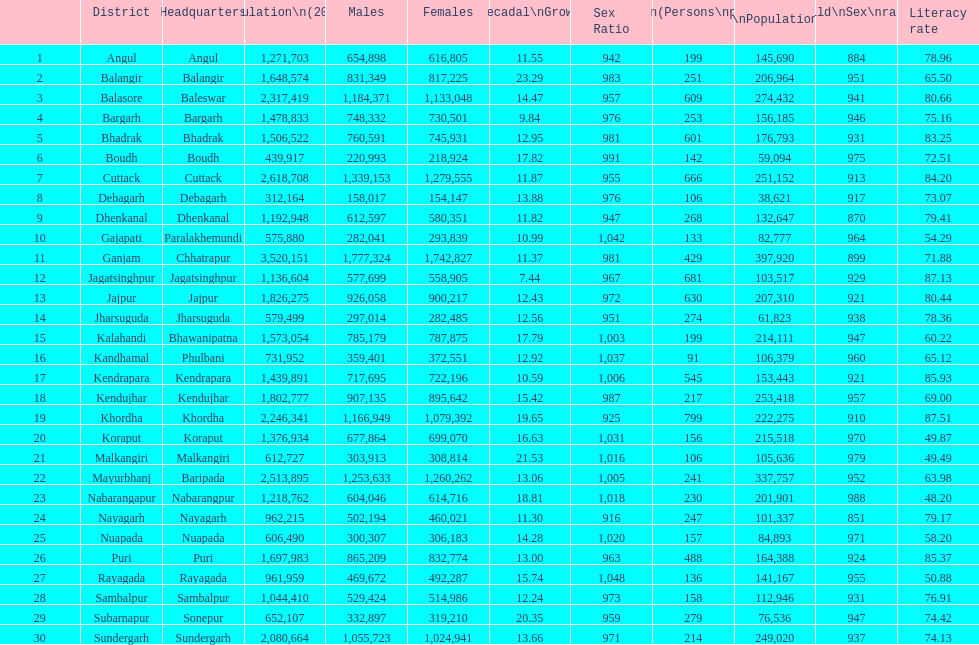In which district was there the maximum population per square kilometer? Khordha. 